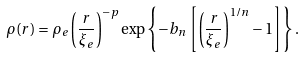<formula> <loc_0><loc_0><loc_500><loc_500>\rho ( r ) = \rho _ { e } \left ( \frac { r } { \xi _ { e } } \right ) ^ { - p } \exp \left \{ - b _ { n } \left [ \left ( \frac { r } { \xi _ { e } } \right ) ^ { 1 / n } - 1 \right ] \right \} .</formula> 